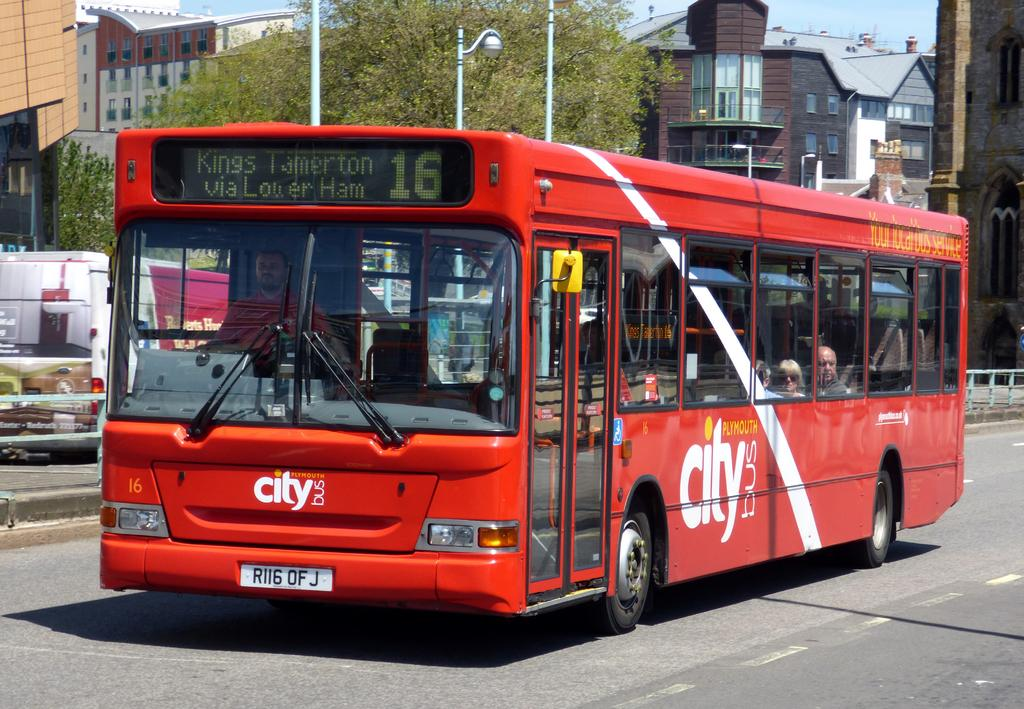What type of vehicle is in the image? There is a red color bus in the image. What is the bus doing in the image? The bus is moving on the road. What can be seen in the background of the image? There are trees and black and brown color buildings visible in the background. What type of wood is the thumb made of in the image? There is no thumb or wood present in the image. 